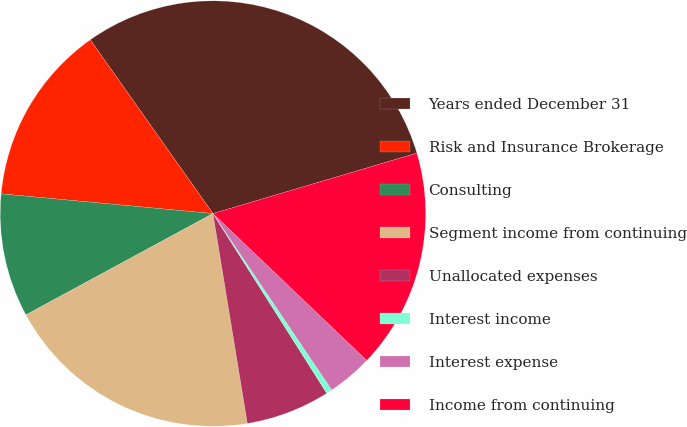Convert chart. <chart><loc_0><loc_0><loc_500><loc_500><pie_chart><fcel>Years ended December 31<fcel>Risk and Insurance Brokerage<fcel>Consulting<fcel>Segment income from continuing<fcel>Unallocated expenses<fcel>Interest income<fcel>Interest expense<fcel>Income from continuing<nl><fcel>30.2%<fcel>13.74%<fcel>9.38%<fcel>19.69%<fcel>6.4%<fcel>0.45%<fcel>3.43%<fcel>16.72%<nl></chart> 